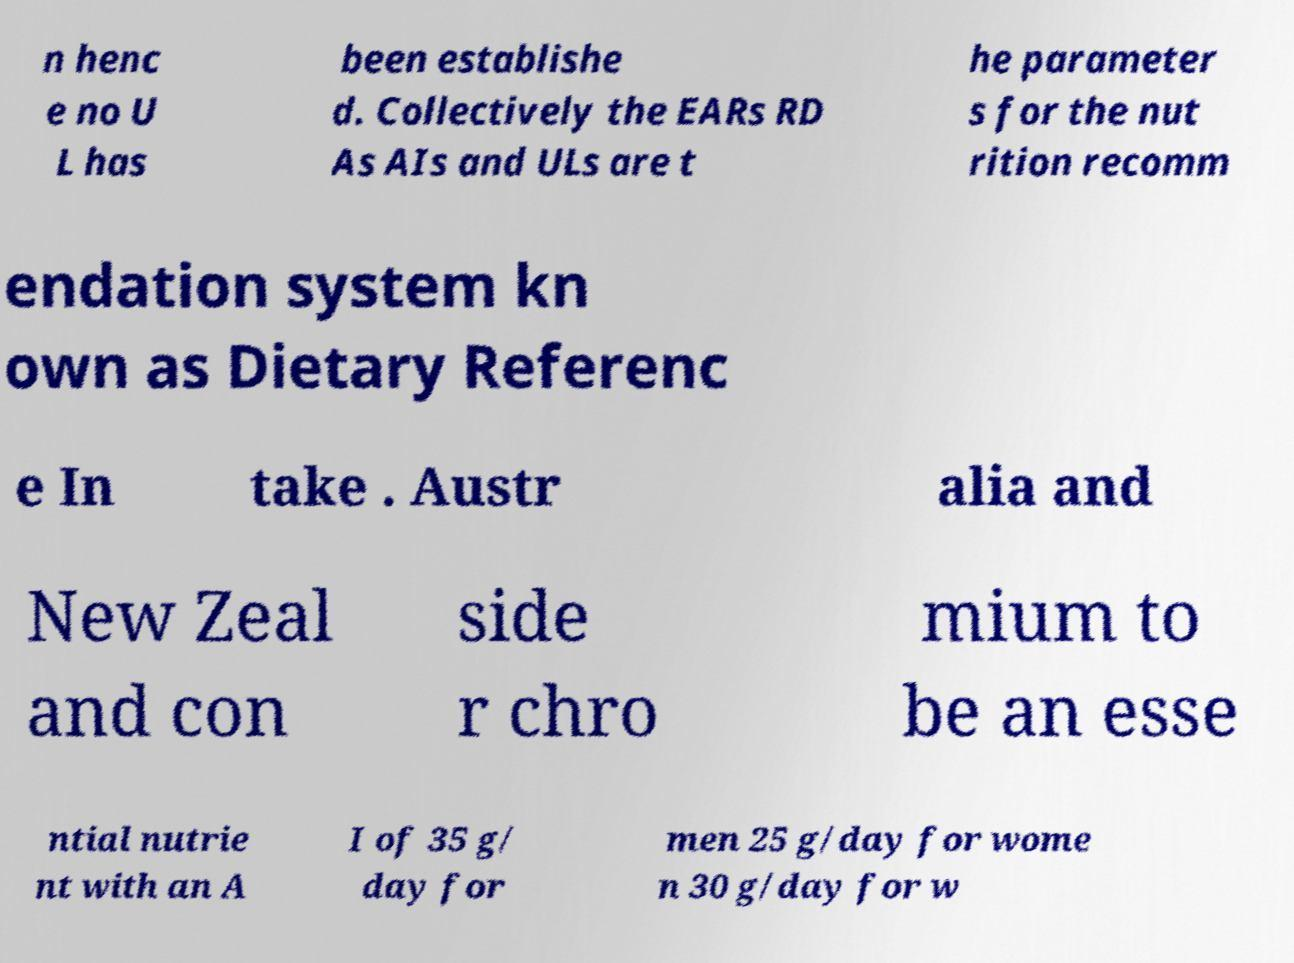There's text embedded in this image that I need extracted. Can you transcribe it verbatim? n henc e no U L has been establishe d. Collectively the EARs RD As AIs and ULs are t he parameter s for the nut rition recomm endation system kn own as Dietary Referenc e In take . Austr alia and New Zeal and con side r chro mium to be an esse ntial nutrie nt with an A I of 35 g/ day for men 25 g/day for wome n 30 g/day for w 